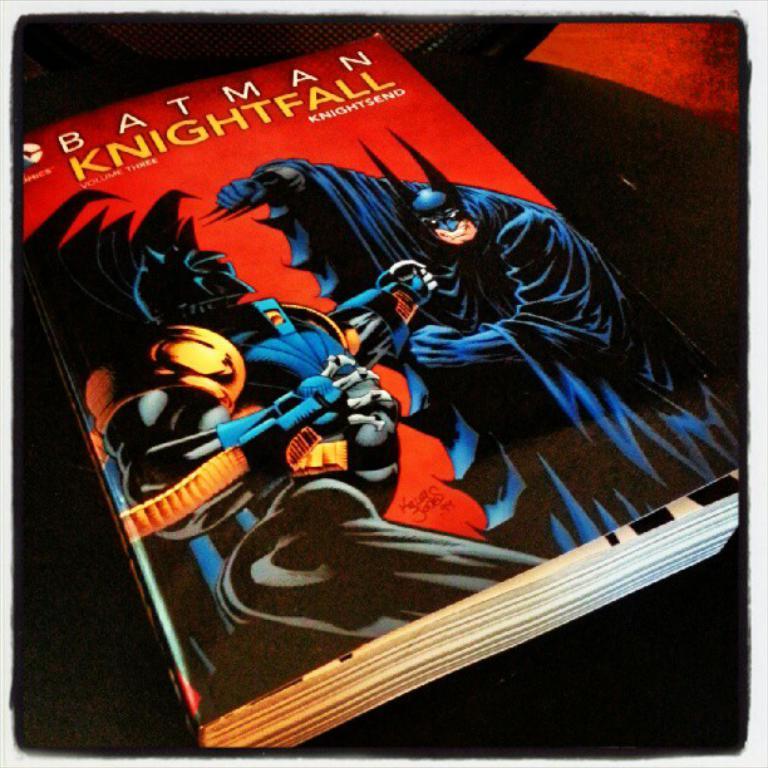What superhero is shown here?
Provide a succinct answer. Batman. 